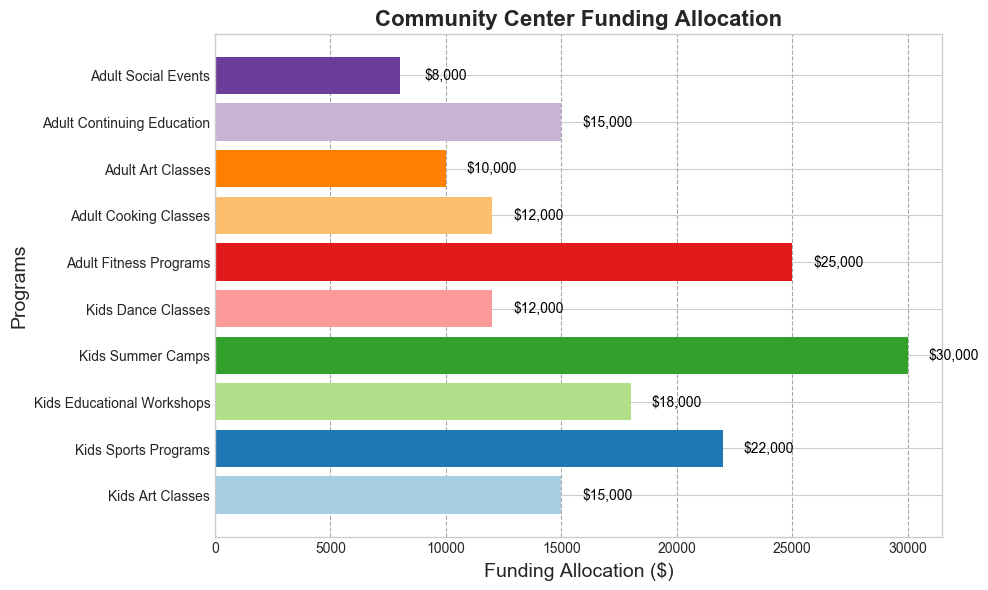What's the total funding allocated to kids' programs? To find the total funding for kids' programs, sum the values allocated to each kids' program: Kids Art Classes ($15,000), Kids Sports Programs ($22,000), Kids Educational Workshops ($18,000), Kids Summer Camps ($30,000), and Kids Dance Classes ($12,000). The total sum is $15,000 + $22,000 + $18,000 + $30,000 + $12,000 = $97,000.
Answer: $97,000 Which program receives the highest amount of funding? By examining the lengths of the bars in the figure, the Kids Summer Camps program has the longest bar, indicating it receives the highest amount of funding at $30,000.
Answer: Kids Summer Camps How much more funding do Kids Sports Programs receive compared to Adult Fitness Programs? Subtract the funding for Adult Fitness Programs ($25,000) from the funding for Kids Sports Programs ($22,000). $22,000 - $25,000 = -$3,000, indicating that Kids Sports Programs receive $3,000 less funding.
Answer: $3,000 less Which program receives the least funding, and how much is it? The Adult Social Events program has the shortest bar on the figure indicating it receives the least amount of funding at $8,000.
Answer: Adult Social Events, $8,000 Are there more kids' programs or adult programs, and by how many? Count the number of bars for kids' programs (5) and for adult programs (5). There are an equal number of kids' and adult programs, both having 5 bars each.
Answer: Equal, 0 What is the average funding allotted to adult programs? Sum the funding values for all adult programs: Adult Fitness Programs ($25,000), Adult Cooking Classes ($12,000), Adult Art Classes ($10,000), Adult Continuing Education ($15,000), and Adult Social Events ($8,000). The sum is $25,000 + $12,000 + $10,000 + $15,000 + $8,000 = $70,000. Divide this sum by the number of adult programs: $70,000 / 5 = $14,000.
Answer: $14,000 How does the funding for Kids Educational Workshops compare to Adult Continuing Education? By visually comparing the bars, both Kids Educational Workshops and Adult Continuing Education receive the same funding amount of $15,000.
Answer: Equal What is the combined funding for all art-related programs? Sum the funding allocated to Kids Art Classes ($15,000), Kids Dance Classes ($12,000), and Adult Art Classes ($10,000). The combined amount is $15,000 + $12,000 + $10,000 = $37,000.
Answer: $37,000 Which category, kids' or adult programs, receives more total funding, and by how much? Total kids' programs funding is $97,000 and adult programs funding is $70,000. Subtract to find the difference: $97,000 - $70,000 = $27,000. Therefore, kids' programs receive $27,000 more funding than adult programs.
Answer: Kids programs, $27,000 more What is the difference in funding between the highest and lowest funded programs? Identify the highest funded program, Kids Summer Camps ($30,000), and the lowest funded program, Adult Social Events ($8,000). The difference is $30,000 - $8,000 = $22,000.
Answer: $22,000 